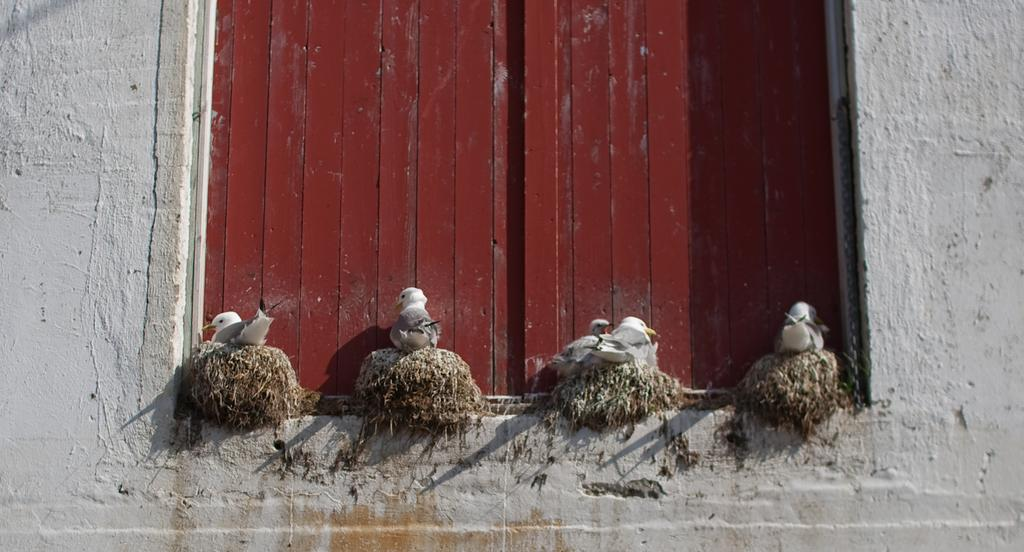How many nests can be seen in the image? There are 4 nests in the image. What type of structure is depicted in the image? The image appears to be a window. What is the color of the window? The window is in red color. How many birds are present in the nests? There are 4 birds in the nests. What design theory is being discussed in the image? There is no discussion of design theory in the image; it simply shows a window with nests and birds. What story is being told in the image? The image does not tell a story; it is a static representation of a window with nests and birds. 